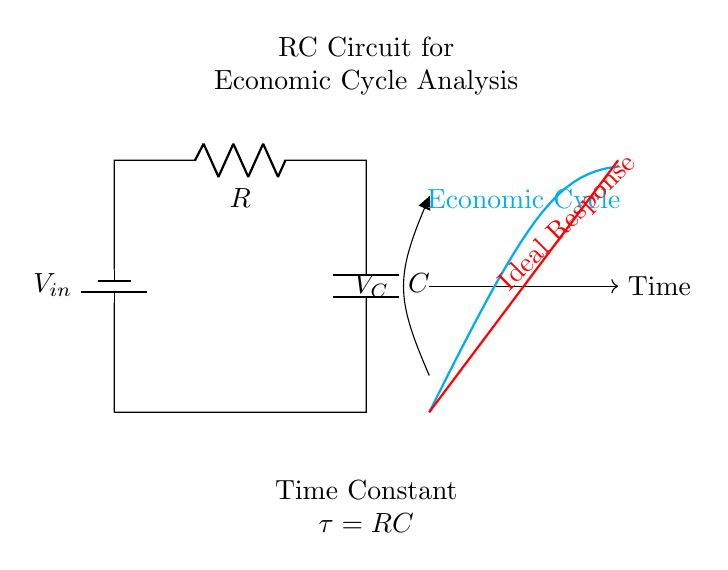What type of circuit is this? This circuit is an RC circuit, as indicated by the presence of a resistor and a capacitor in series connected to a voltage source.
Answer: RC circuit What does the "V_C" label indicate? "V_C" represents the voltage across the capacitor within the circuit, illustrating how voltage varies as the capacitor charges and discharges.
Answer: Voltage across capacitor What is the time constant symbol in this circuit? The time constant in this RC circuit is denoted by the symbol tau, which is indicated below the circuit diagram as "τ = RC."
Answer: Tau What does the cyan curve represent? The cyan curve represents the economic cycle, demonstrating changes in economic activity over time as it relates to the behavior of the RC circuit.
Answer: Economic cycle Explain the relationship between the time constant and economic cycles. The time constant (tau) indicates how quickly the voltage across the capacitor responds to changes in input voltage, similar to how quickly economic cycles respond to varying market conditions. A larger time constant means slower responses, indicating prolonged economic phases.
Answer: Time constant affects cycle response speed Which component determines how fast the circuit responds? The capacitor determines the response speed; its capacitance value directly affects the time constant, thereby influencing how quickly the circuit can charge or discharge.
Answer: Capacitor What value is required for the resistor to achieve a specific time constant of one second if the capacitor value is one farad? Since the time constant τ (tau) is defined as the product of R and C, for a time constant of one second and a capacitor value of one farad, the resistor value must also be one ohm.
Answer: One ohm 